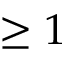<formula> <loc_0><loc_0><loc_500><loc_500>\geq 1</formula> 